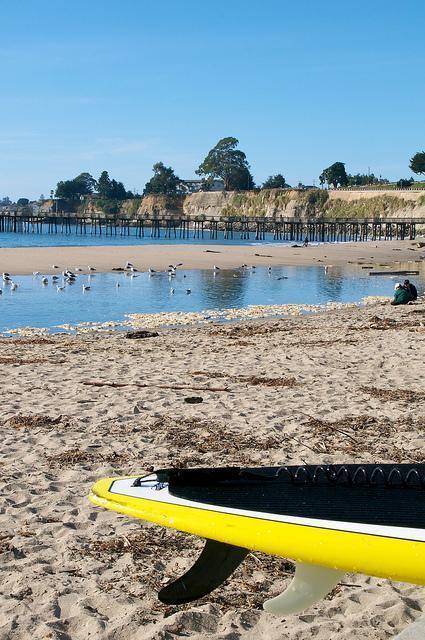How many boats are on the water?
Give a very brief answer. 0. 